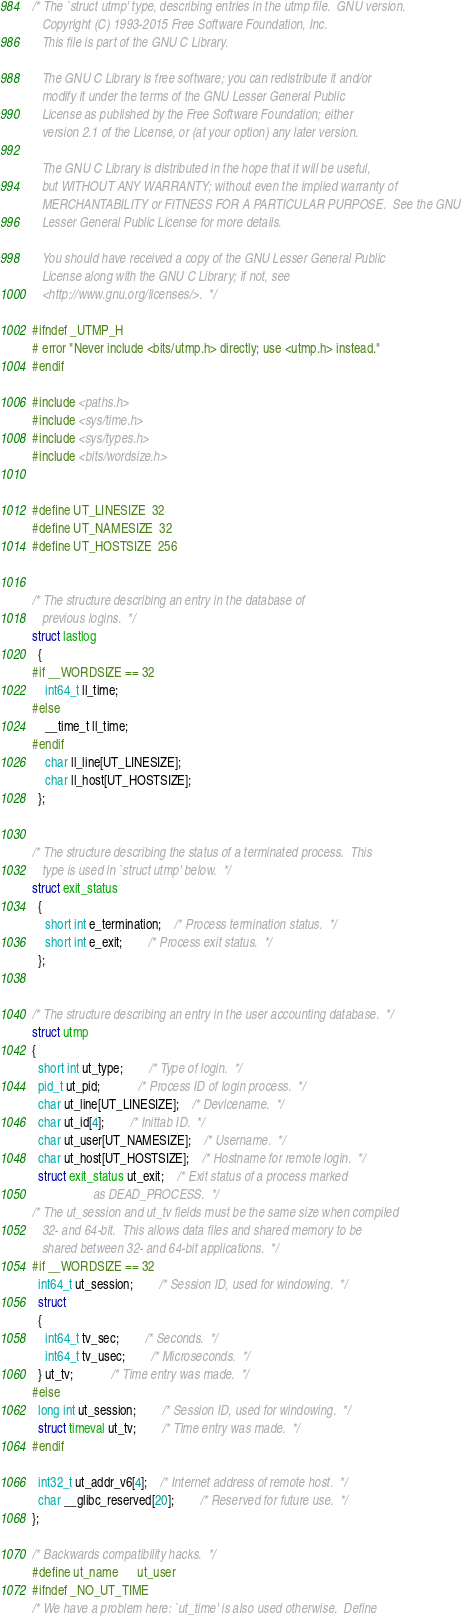<code> <loc_0><loc_0><loc_500><loc_500><_C_>/* The `struct utmp' type, describing entries in the utmp file.  GNU version.
   Copyright (C) 1993-2015 Free Software Foundation, Inc.
   This file is part of the GNU C Library.

   The GNU C Library is free software; you can redistribute it and/or
   modify it under the terms of the GNU Lesser General Public
   License as published by the Free Software Foundation; either
   version 2.1 of the License, or (at your option) any later version.

   The GNU C Library is distributed in the hope that it will be useful,
   but WITHOUT ANY WARRANTY; without even the implied warranty of
   MERCHANTABILITY or FITNESS FOR A PARTICULAR PURPOSE.  See the GNU
   Lesser General Public License for more details.

   You should have received a copy of the GNU Lesser General Public
   License along with the GNU C Library; if not, see
   <http://www.gnu.org/licenses/>.  */

#ifndef _UTMP_H
# error "Never include <bits/utmp.h> directly; use <utmp.h> instead."
#endif

#include <paths.h>
#include <sys/time.h>
#include <sys/types.h>
#include <bits/wordsize.h>


#define UT_LINESIZE	32
#define UT_NAMESIZE	32
#define UT_HOSTSIZE	256


/* The structure describing an entry in the database of
   previous logins.  */
struct lastlog
  {
#if __WORDSIZE == 32
    int64_t ll_time;
#else
    __time_t ll_time;
#endif
    char ll_line[UT_LINESIZE];
    char ll_host[UT_HOSTSIZE];
  };


/* The structure describing the status of a terminated process.  This
   type is used in `struct utmp' below.  */
struct exit_status
  {
    short int e_termination;	/* Process termination status.  */
    short int e_exit;		/* Process exit status.  */
  };


/* The structure describing an entry in the user accounting database.  */
struct utmp
{
  short int ut_type;		/* Type of login.  */
  pid_t ut_pid;			/* Process ID of login process.  */
  char ut_line[UT_LINESIZE];	/* Devicename.  */
  char ut_id[4];		/* Inittab ID.  */
  char ut_user[UT_NAMESIZE];	/* Username.  */
  char ut_host[UT_HOSTSIZE];	/* Hostname for remote login.  */
  struct exit_status ut_exit;	/* Exit status of a process marked
				   as DEAD_PROCESS.  */
/* The ut_session and ut_tv fields must be the same size when compiled
   32- and 64-bit.  This allows data files and shared memory to be
   shared between 32- and 64-bit applications.  */
#if __WORDSIZE == 32
  int64_t ut_session;		/* Session ID, used for windowing.  */
  struct
  {
    int64_t tv_sec;		/* Seconds.  */
    int64_t tv_usec;		/* Microseconds.  */
  } ut_tv;			/* Time entry was made.  */
#else
  long int ut_session;		/* Session ID, used for windowing.  */
  struct timeval ut_tv;		/* Time entry was made.  */
#endif

  int32_t ut_addr_v6[4];	/* Internet address of remote host.  */
  char __glibc_reserved[20];		/* Reserved for future use.  */
};

/* Backwards compatibility hacks.  */
#define ut_name		ut_user
#ifndef _NO_UT_TIME
/* We have a problem here: `ut_time' is also used otherwise.  Define</code> 